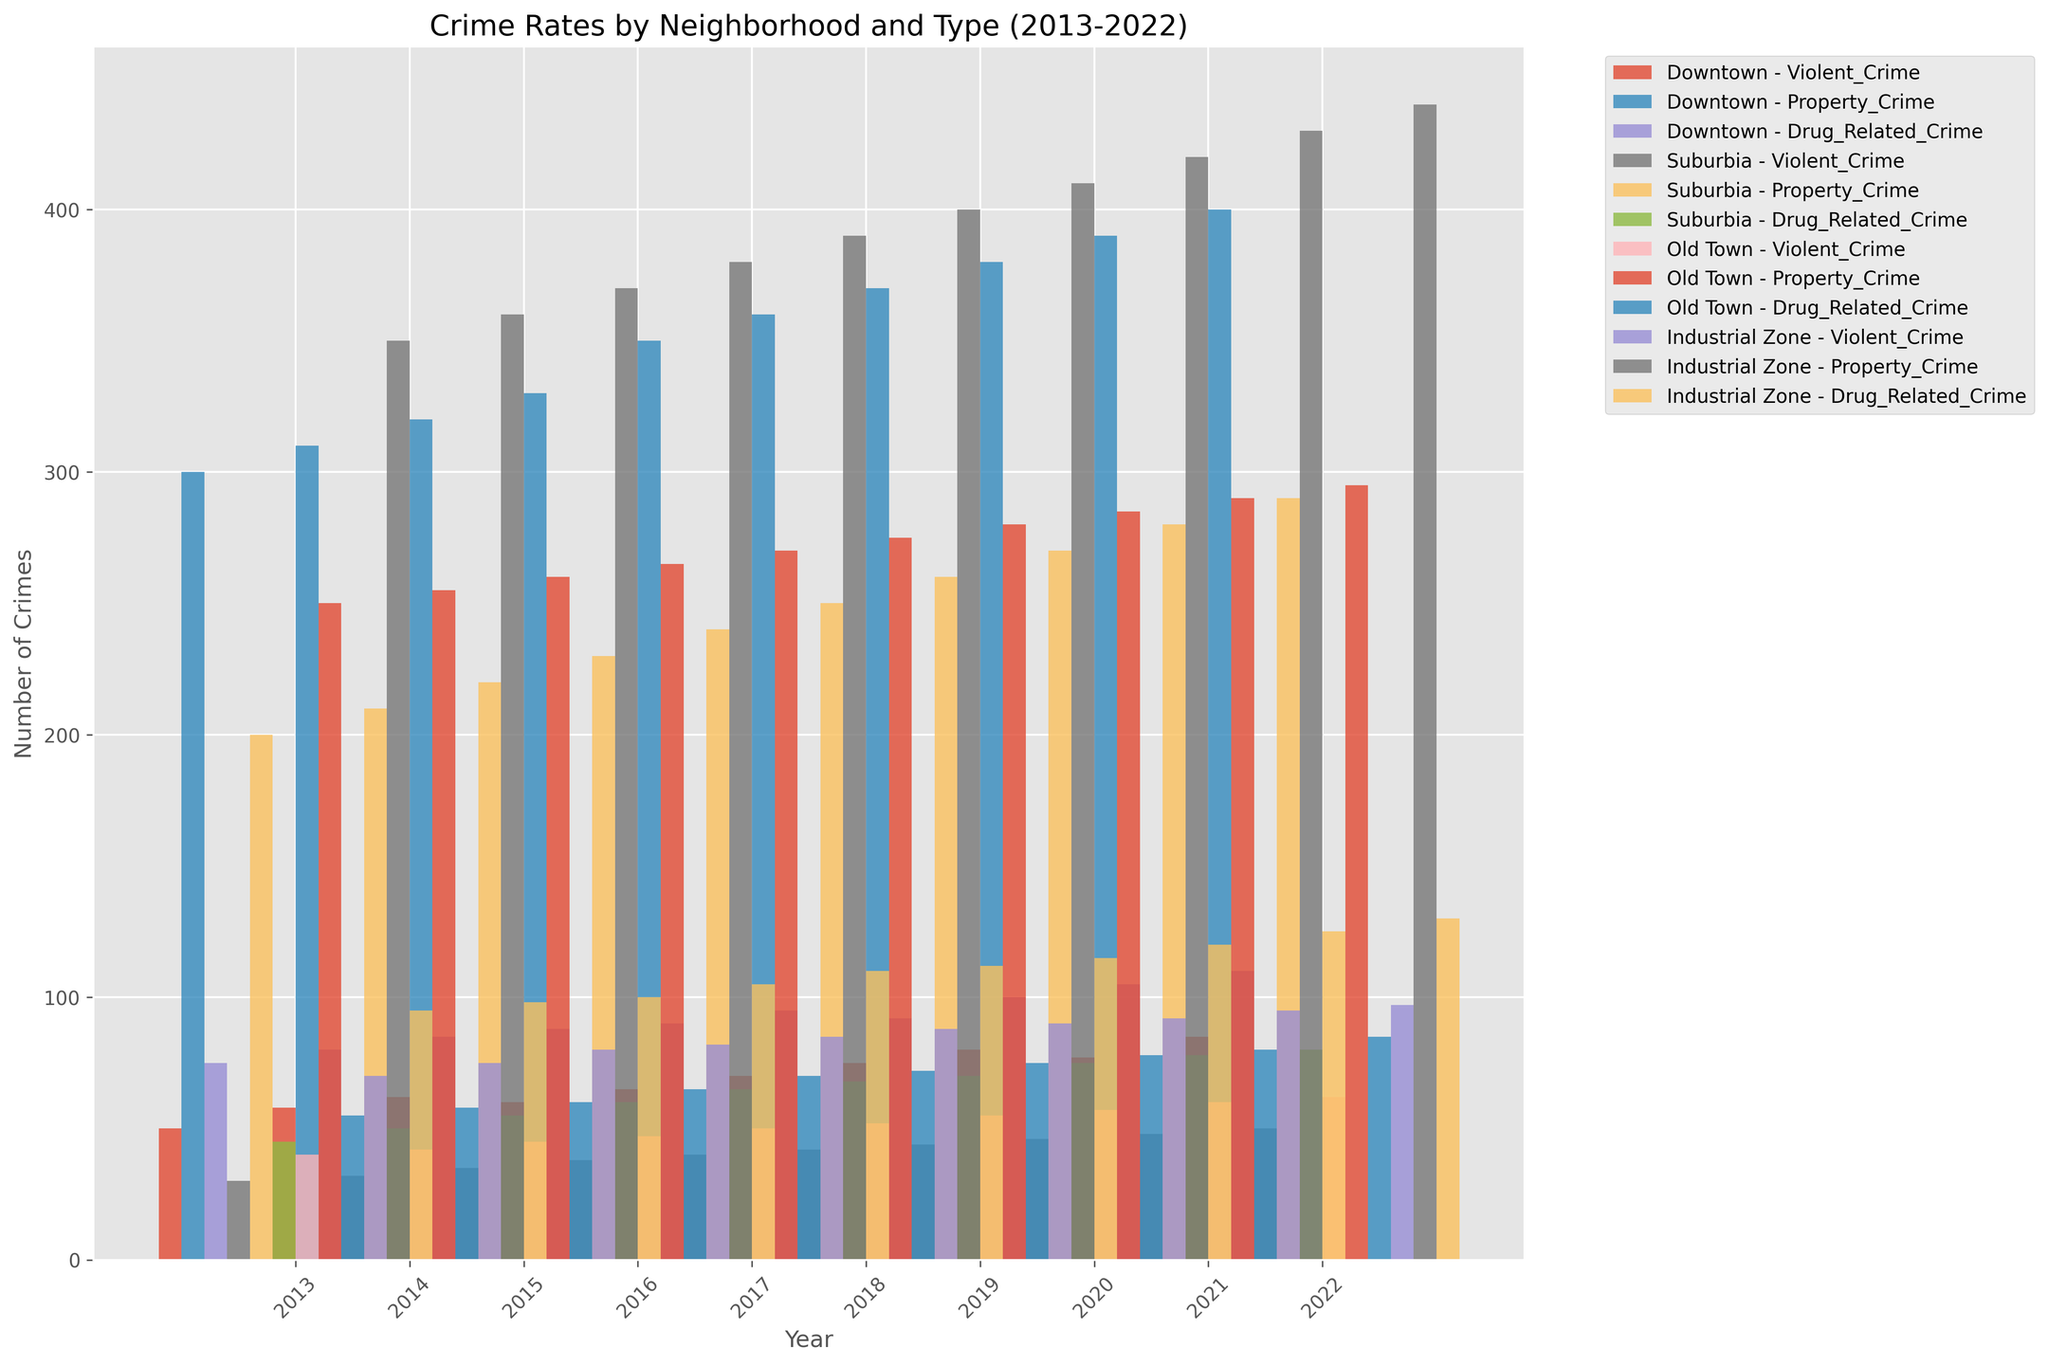What is the trend of violent crime in Downtown from 2013 to 2022? Look at the bars labeled as "Downtown - Violent_Crime" over the years 2013 to 2022. Observe if they generally go up, down, or stay the same.
Answer: Increasing Which neighborhood had the highest number of property crimes in 2020? Compare the heights of the bars corresponding to "Property_Crime" for each neighborhood in the year 2020.
Answer: Downtown How does the number of drug-related crimes in Suburbia in 2022 compare to the number in Old Town in 2022? Compare the height of the bar labeled "Suburbia - Drug_Related_Crime" for 2022 to the bar labeled "Old Town - Drug_Related_Crime" for 2022.
Answer: Lower How much did the number of violent crimes increase in the Industrial Zone between 2013 and 2022? Subtract the height of the bar labeled "Industrial Zone - Violent_Crime" in 2013 from the height of the corresponding bar in 2022.
Answer: 27 Which neighborhood had a consistent increase in property crimes every year from 2013 to 2022? Look at the bars for each neighborhood labeled "Property_Crime" for a steady year-over-year increase.
Answer: Downtown What is the average number of drug-related crimes in Old Town from 2013 to 2022? Sum the heights of the "Old Town - Drug_Related_Crime" bars from 2013 to 2022 and divide by the number of years (10).
Answer: 70 Which neighborhood has the least variation in violent crime from 2013 to 2022? Compare the range of bar heights labeled "Violent_Crime" for each neighborhood.
Answer: Suburbia What was the total number of violent crimes across all neighborhoods in 2021? Sum the heights of all bars labeled "Violent_Crime" for each neighborhood in 2021.
Answer: 280 Are property crimes in Suburbia more consistent over the years compared to other neighborhoods? Compare the year-over-year changes in the height of the "Property_Crime" bars for Suburbia with those of other neighborhoods.
Answer: Yes Compare the increase in violent crimes in Downtown and the Industrial Zone from 2013 to 2022. Find the difference in the height of the "Violent_Crime" bars for Downtown and the Industrial Zone between 2013 and 2022 and compare the two differences.
Answer: Industrial Zone has a greater increase 